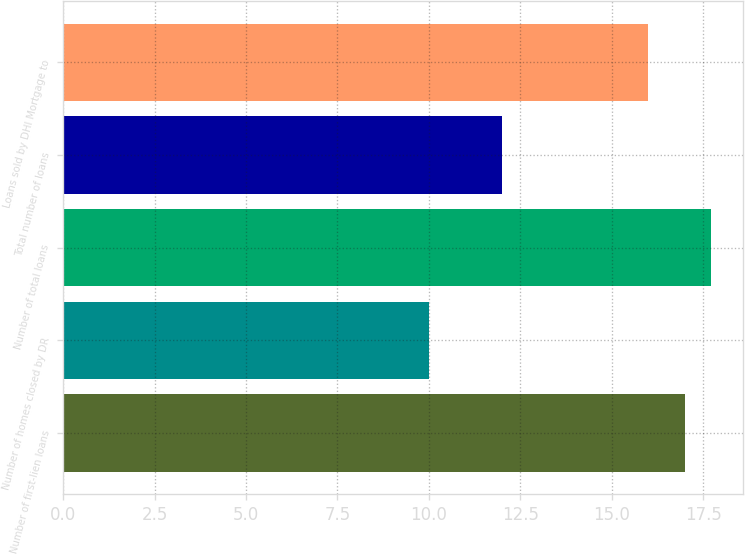Convert chart. <chart><loc_0><loc_0><loc_500><loc_500><bar_chart><fcel>Number of first-lien loans<fcel>Number of homes closed by DR<fcel>Number of total loans<fcel>Total number of loans<fcel>Loans sold by DHI Mortgage to<nl><fcel>17<fcel>10<fcel>17.7<fcel>12<fcel>16<nl></chart> 